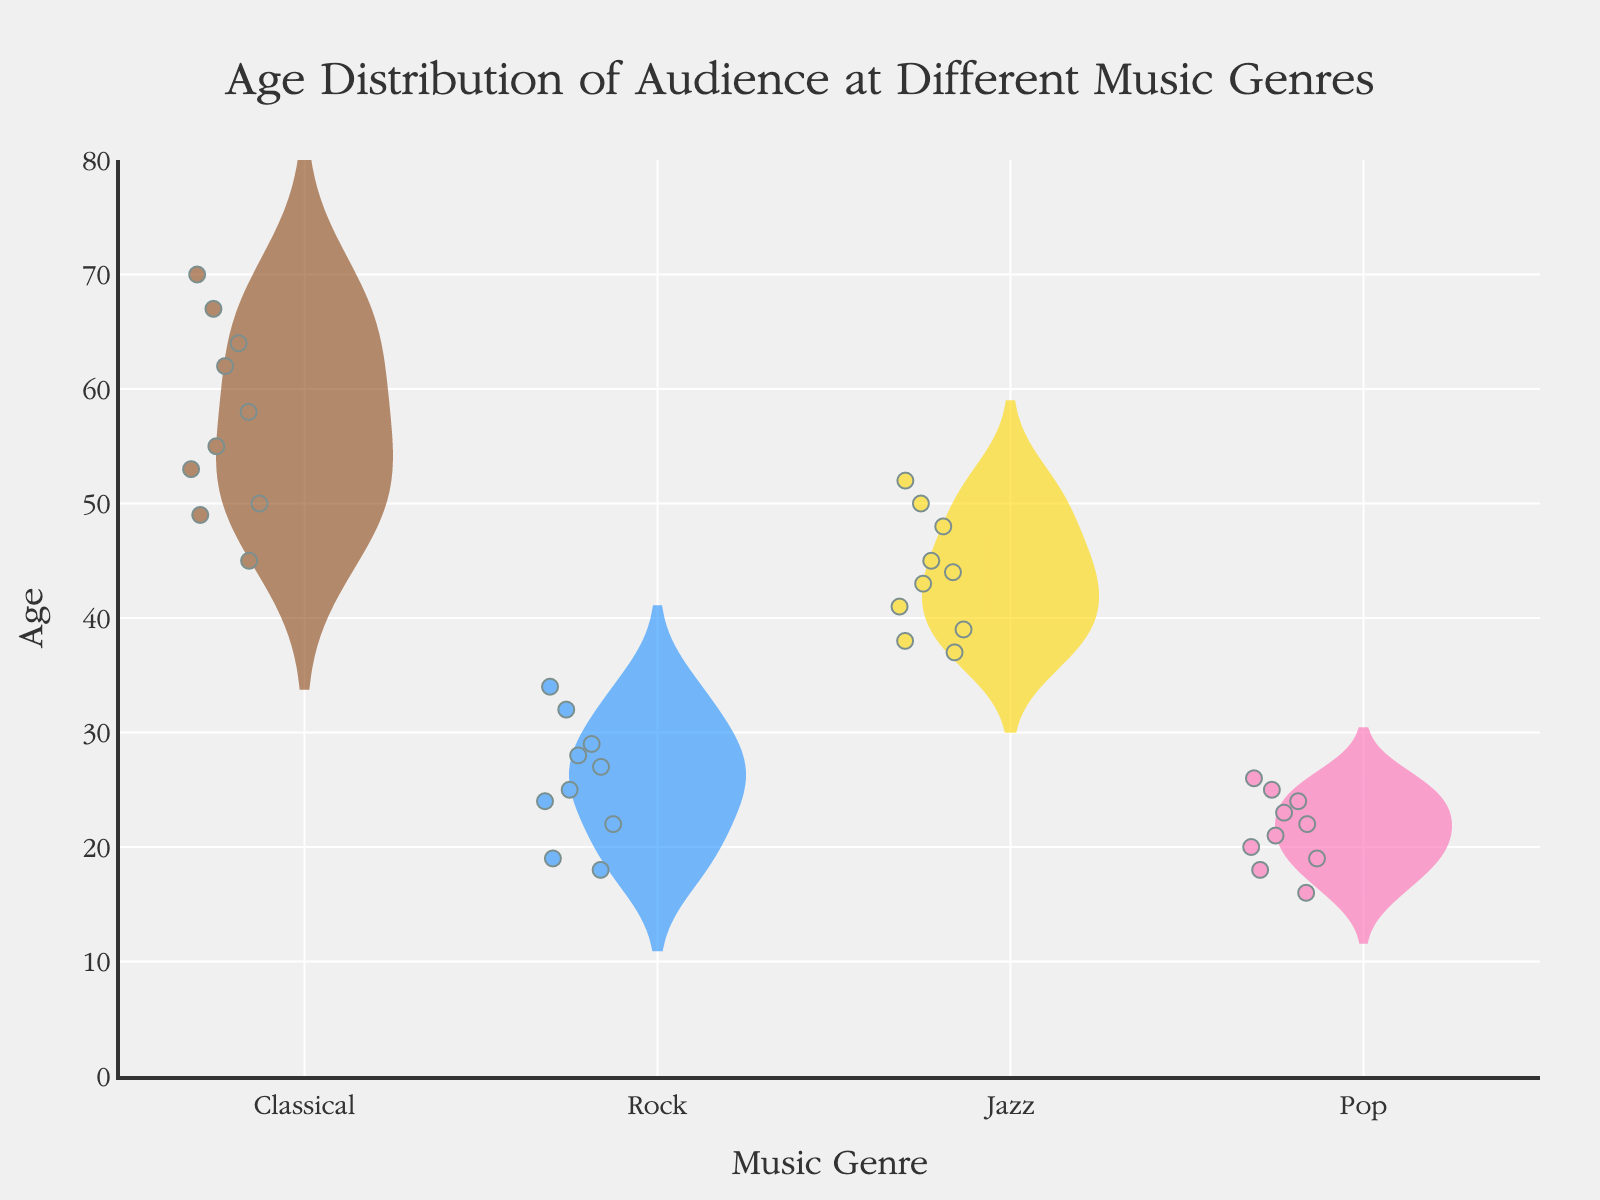what is the title of the figure? The title of the figure is displayed at the top center and is in a larger font size.
Answer: Age Distribution of Audience at Different Music Genres which genre has the most data points? By observing the number of jittered points on the violin plots, we can determine which genre has the most data points. The genre with the most points is Rock.
Answer: Rock what is the median age of classical music audience? The median age is indicated by the horizontal line within the box plot of the violin. For the Classical genre, the median age is around 56.
Answer: 56 which genre has the youngest audience? By looking at the overall shape and range of the violin plots, we can see which has the lowest age distribution. Pop has the youngest audience with ages ranging mostly between 16 and 26.
Answer: Pop how does the age distribution of classical music compare to rock music? Comparison involves observing the shape, spread, and center (mean and median) of the violin plots. Classical has a higher age range (45 to 70) and higher median and mean ages compared to Rock, which has ages primarily between 18 and 34.
Answer: Classical is older on average what is the range of ages for the jazz audience? The range is calculated by subtracting the minimum age from the maximum age in the Jazz violin plot. The ages range from about 37 to 52.
Answer: 15 years what can be said about the variability of ages in the pop audience compared to the jazz audience? Variability can be assessed by looking at the spread and width of the violin plots. Pop has a more narrow and less variable age range compared to Jazz, indicating less variability.
Answer: Pop has less variability which genre has the oldest audience on average? This can be determined by comparing the positions of the mean and median lines of each genre's violin plot. Classical has the oldest audience on average.
Answer: Classical what age appears most frequently in the classical music audience? The mode can be seen where the violin plot is widest. For Classical, ages around 62 appear most frequently.
Answer: Around 62 is there any overlap in the age distributions of the rock and jazz audiences? Overlap can be observed where the violin plots of Rock and Jazz intersect on the y-axis. Both genres have an age overlap in the range of roughly 35-40.
Answer: Yes, there is overlap between 35 and 40 